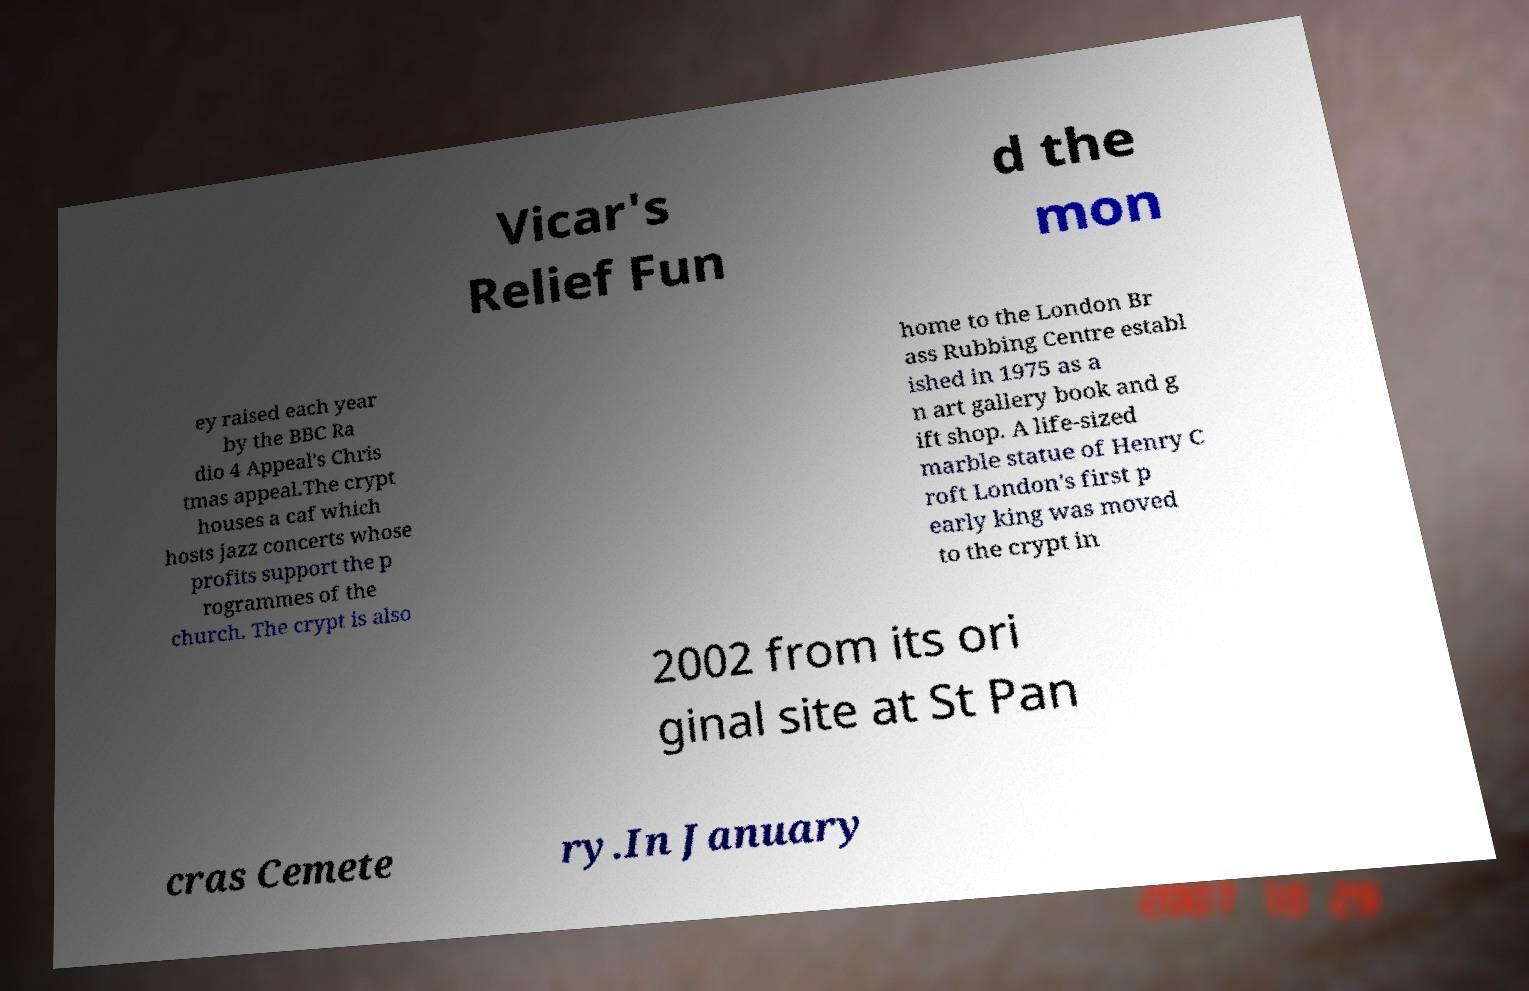I need the written content from this picture converted into text. Can you do that? Vicar's Relief Fun d the mon ey raised each year by the BBC Ra dio 4 Appeal's Chris tmas appeal.The crypt houses a caf which hosts jazz concerts whose profits support the p rogrammes of the church. The crypt is also home to the London Br ass Rubbing Centre establ ished in 1975 as a n art gallery book and g ift shop. A life-sized marble statue of Henry C roft London's first p early king was moved to the crypt in 2002 from its ori ginal site at St Pan cras Cemete ry.In January 